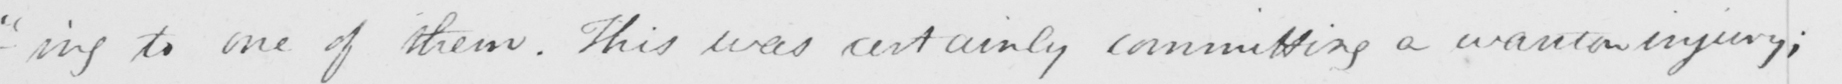What text is written in this handwritten line? - " ing to one of them . This was certainly committing a wanton injury ; 